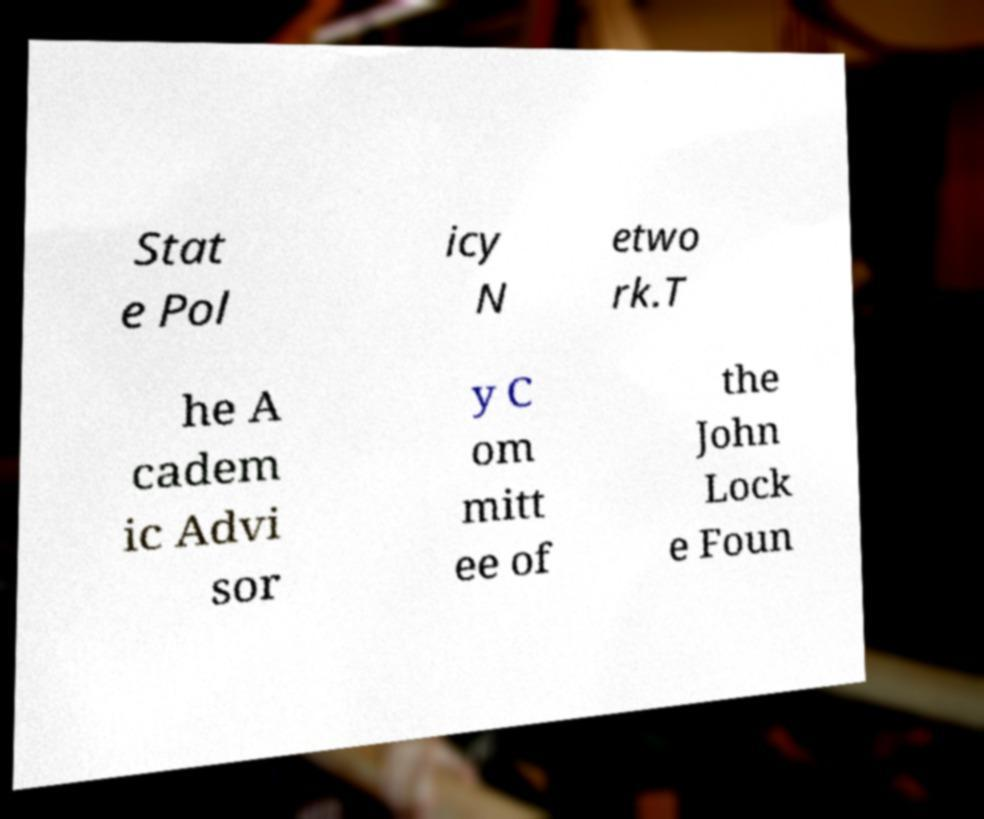Can you accurately transcribe the text from the provided image for me? Stat e Pol icy N etwo rk.T he A cadem ic Advi sor y C om mitt ee of the John Lock e Foun 